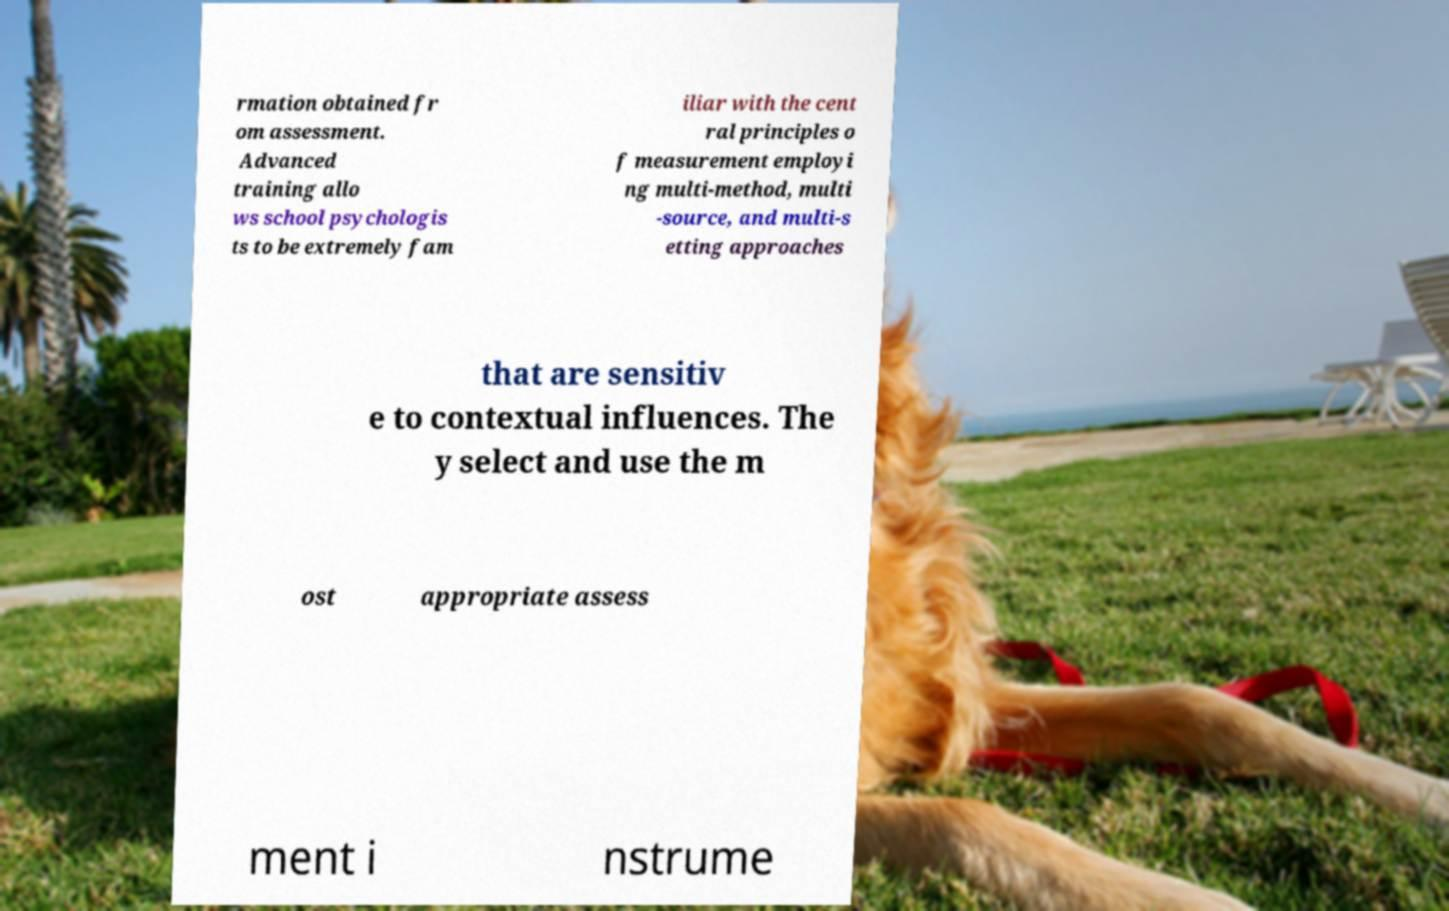Please read and relay the text visible in this image. What does it say? rmation obtained fr om assessment. Advanced training allo ws school psychologis ts to be extremely fam iliar with the cent ral principles o f measurement employi ng multi-method, multi -source, and multi-s etting approaches that are sensitiv e to contextual influences. The y select and use the m ost appropriate assess ment i nstrume 